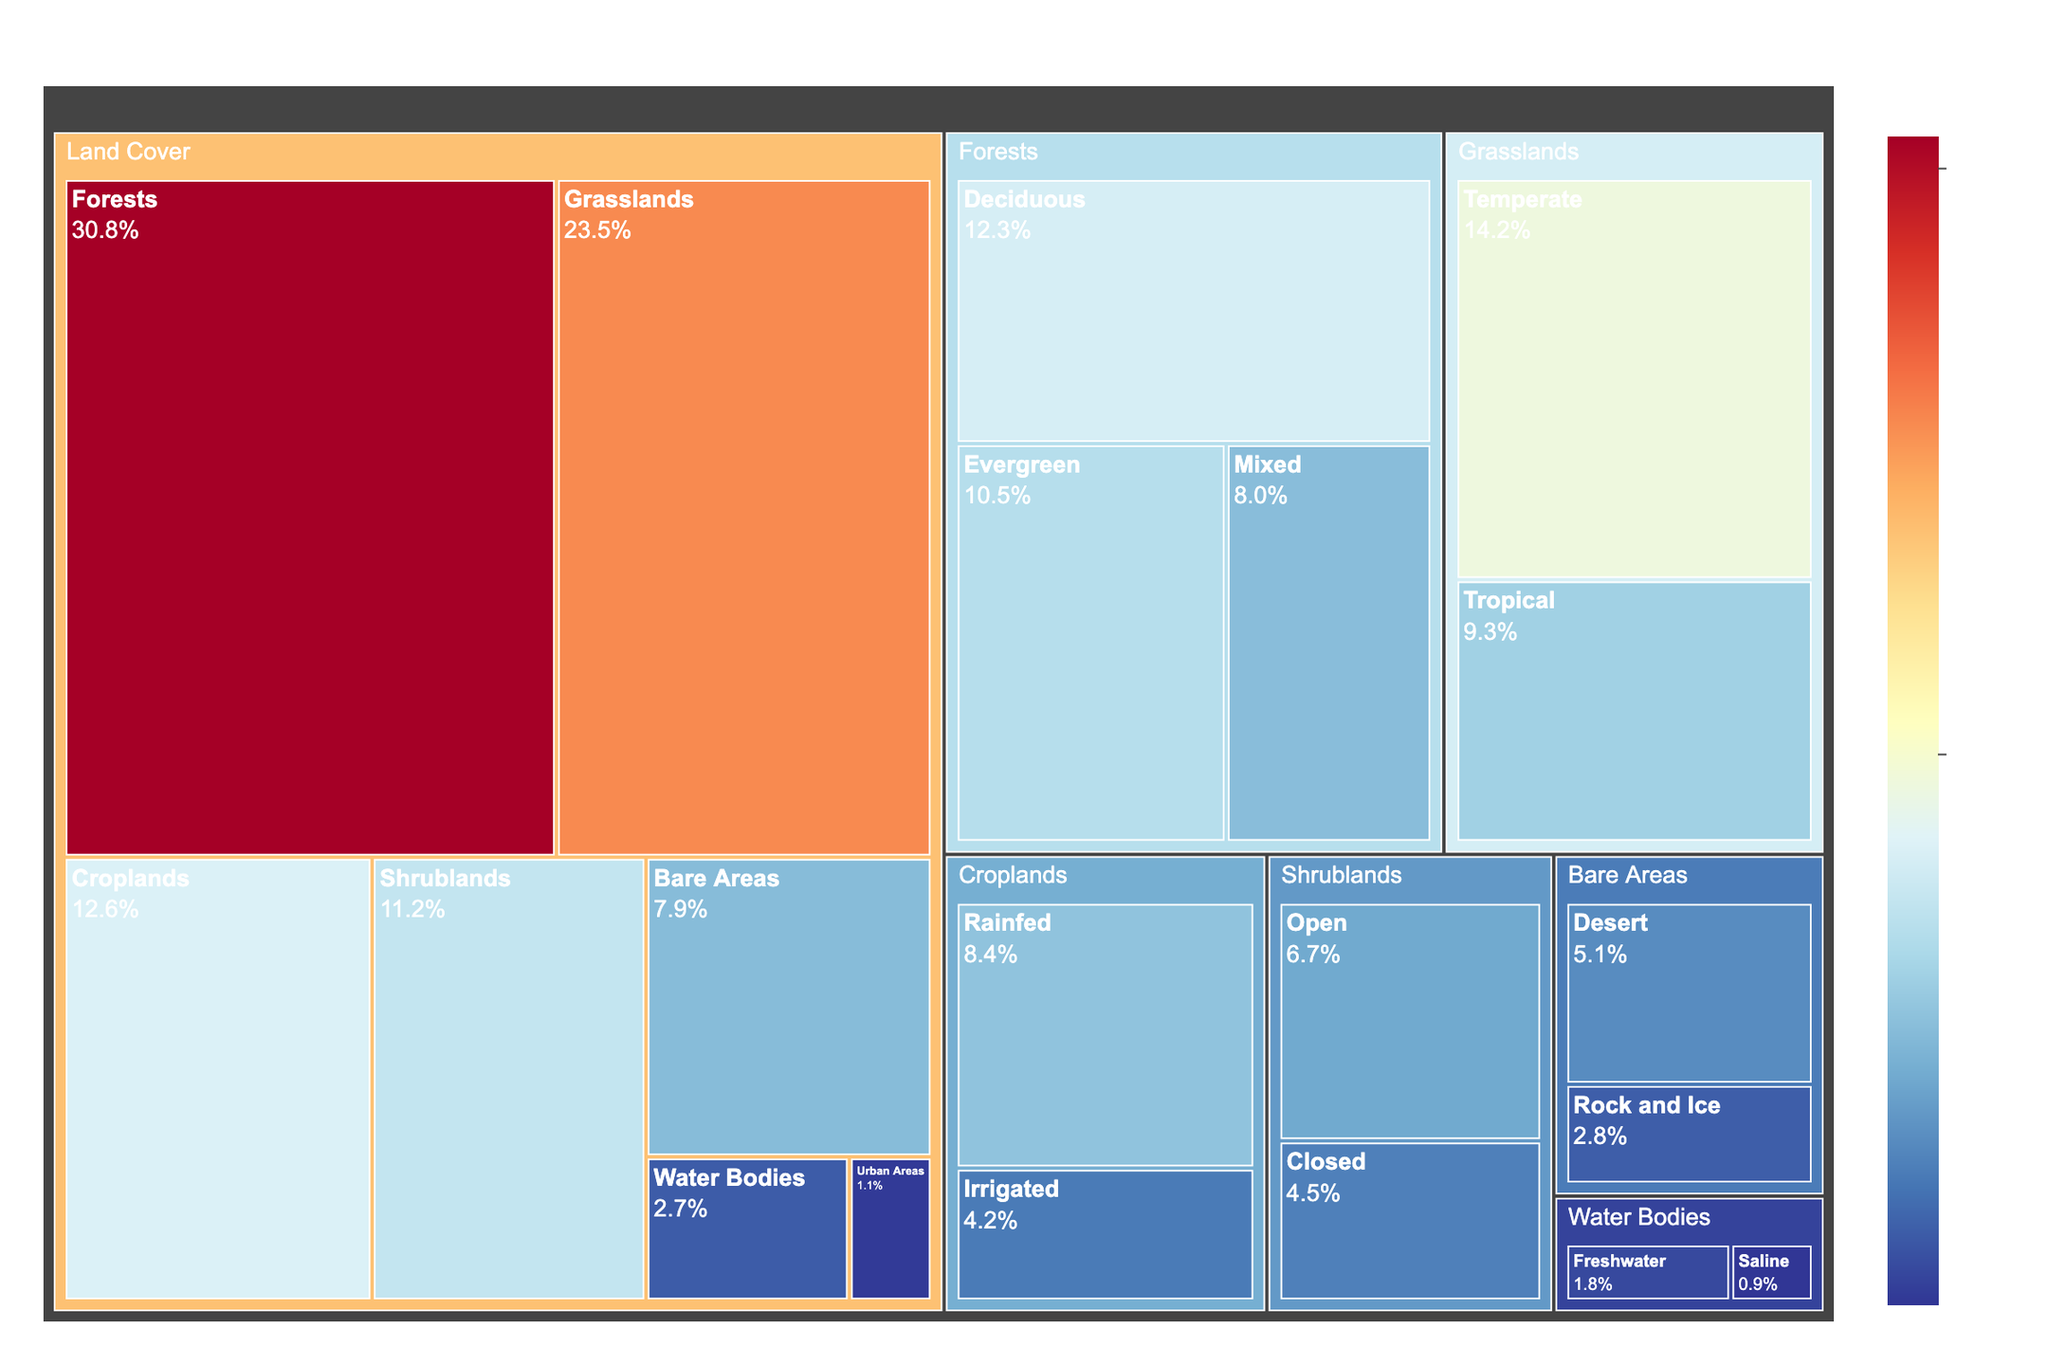What's the title of the treemap? To find the title, look at the text displayed prominently at the top of the treemap.
Answer: Global Land Cover Classification What percentage of land cover is classified as Grasslands? Check the percentage value associated with the Grasslands category.
Answer: 23.5% Which subcategory of Forests has the highest percentage? Look at the subcategories under Forests (Deciduous, Evergreen, Mixed) and compare their percentages to identify the highest one.
Answer: Deciduous What is the combined percentage of Rainfed and Irrigated Croplands? Add the percentage values of Rainfed (8.4%) and Irrigated (4.2%) Croplands together.
Answer: 8.4% + 4.2% = 12.6% Which has a higher percentage: Temperate Grasslands or Tropical Grasslands? Compare the percentage values of Temperate Grasslands (14.2%) and Tropical Grasslands (9.3%).
Answer: Temperate Grasslands What is the percentage difference between Open Shrublands and Closed Shrublands? Subtract the percentage of Closed Shrublands (4.5%) from Open Shrublands (6.7%).
Answer: 6.7% - 4.5% = 2.2% How does the percentage of Water Bodies compare to Urban Areas? Compare percentage values of Water Bodies (2.7%) and Urban Areas (1.1%).
Answer: Water Bodies has a higher percentage Which land cover type has the least percentage and what is it? Find the land cover type with the smallest percentage by examining the values for all types.
Answer: Urban Areas, 1.1% What is the total percentage of Bare Areas? Sum the percentage values of the subcategories Desert (5.1%) and Rock and Ice (2.8%) under Bare Areas.
Answer: 5.1% + 2.8% = 7.9% 